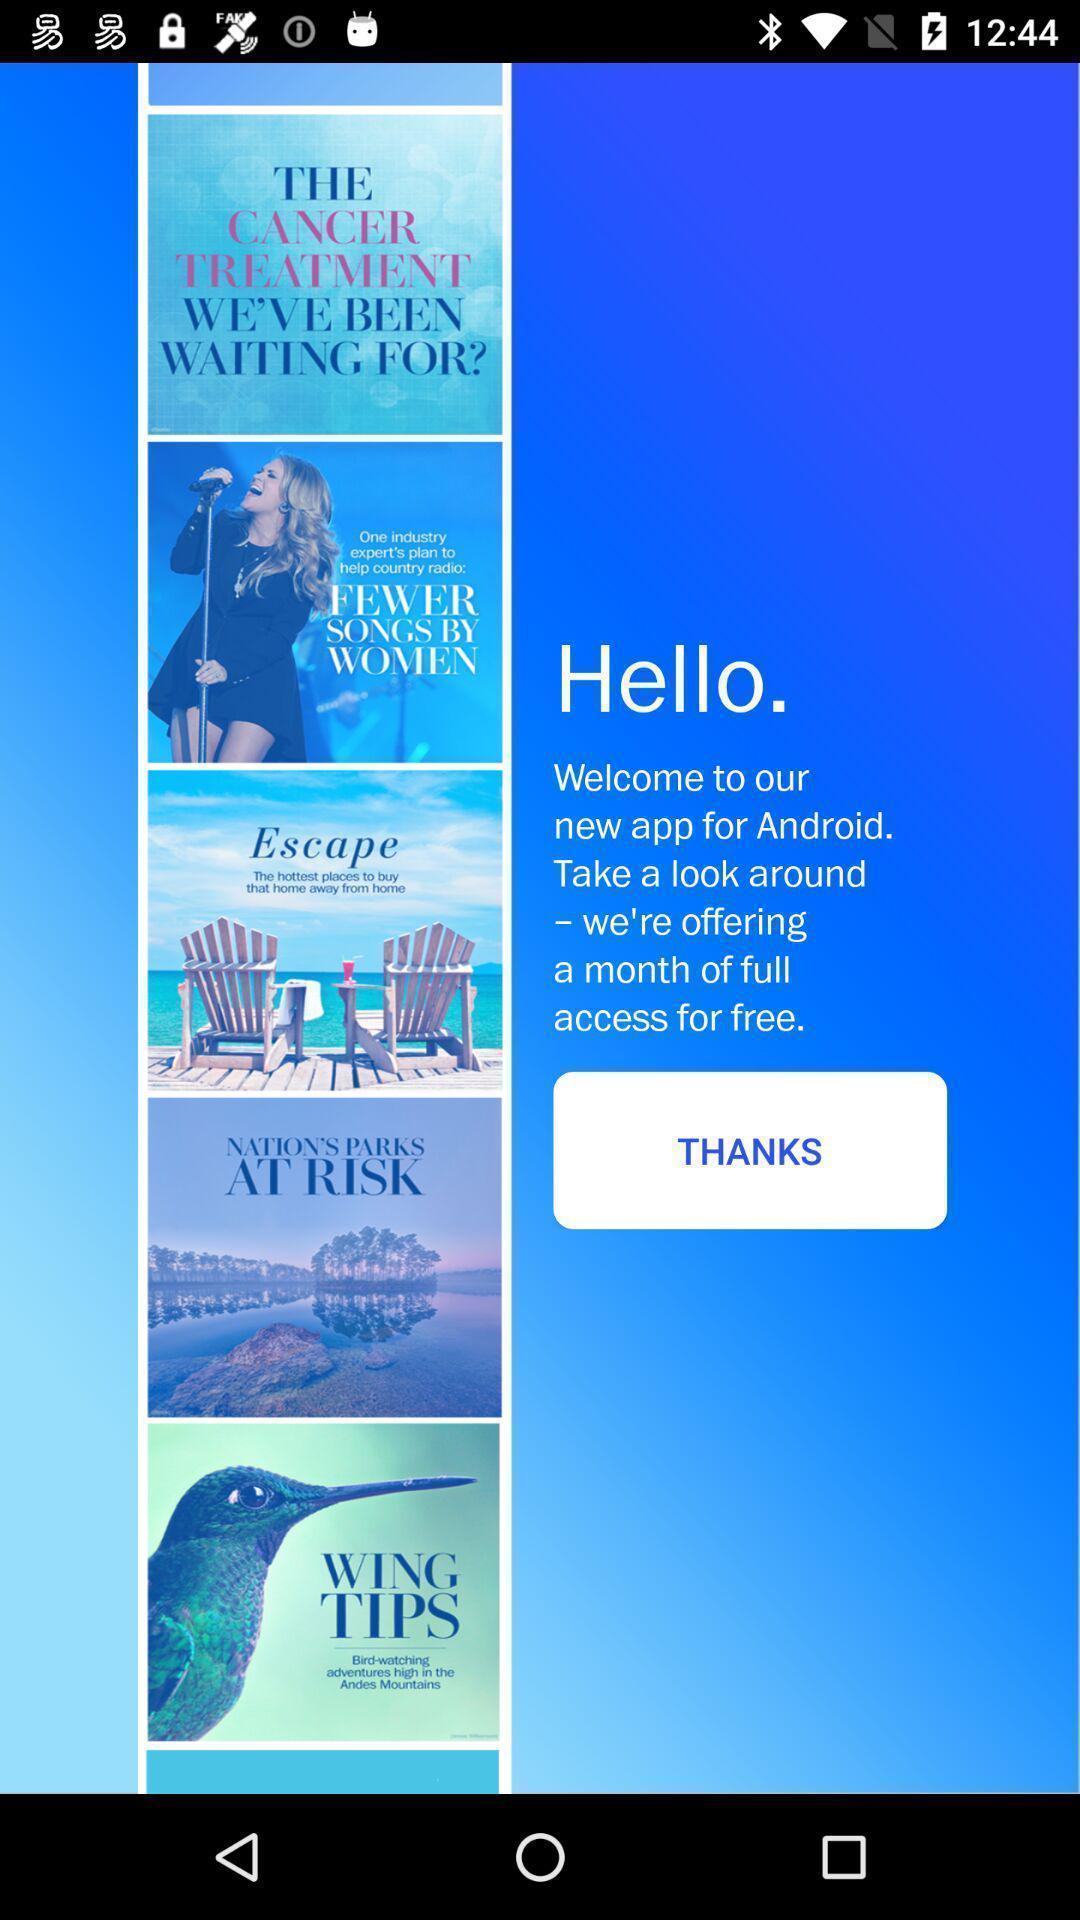Summarize the main components in this picture. Welcome page of social app. 